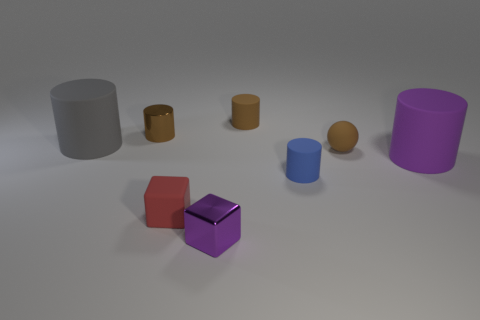Subtract all brown metallic cylinders. How many cylinders are left? 4 Add 2 big cylinders. How many objects exist? 10 Subtract all purple cubes. How many cubes are left? 1 Subtract 1 cylinders. How many cylinders are left? 4 Subtract all gray cylinders. Subtract all blue blocks. How many cylinders are left? 4 Subtract all cyan balls. How many blue cylinders are left? 1 Subtract all small metal things. Subtract all small purple blocks. How many objects are left? 5 Add 1 big things. How many big things are left? 3 Add 8 rubber balls. How many rubber balls exist? 9 Subtract 0 green cubes. How many objects are left? 8 